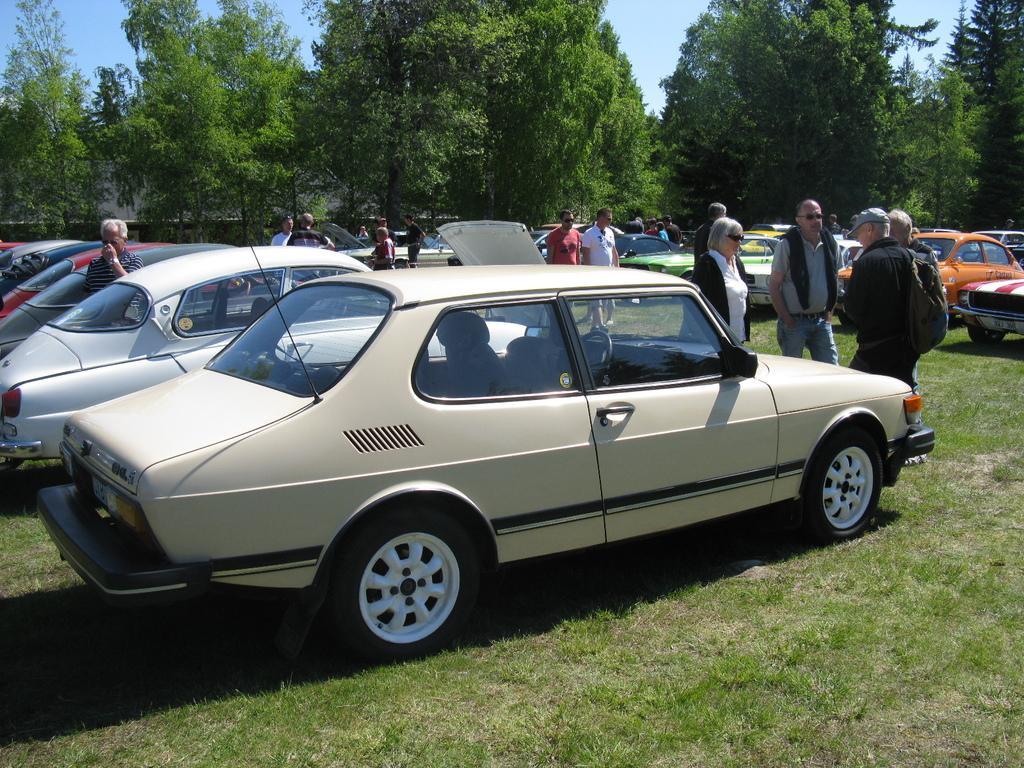In one or two sentences, can you explain what this image depicts? In this image there are so many cars parked on the ground one beside the other. In between the cars there are few people walking on the ground. In the background there are trees. At the top there is sky. 